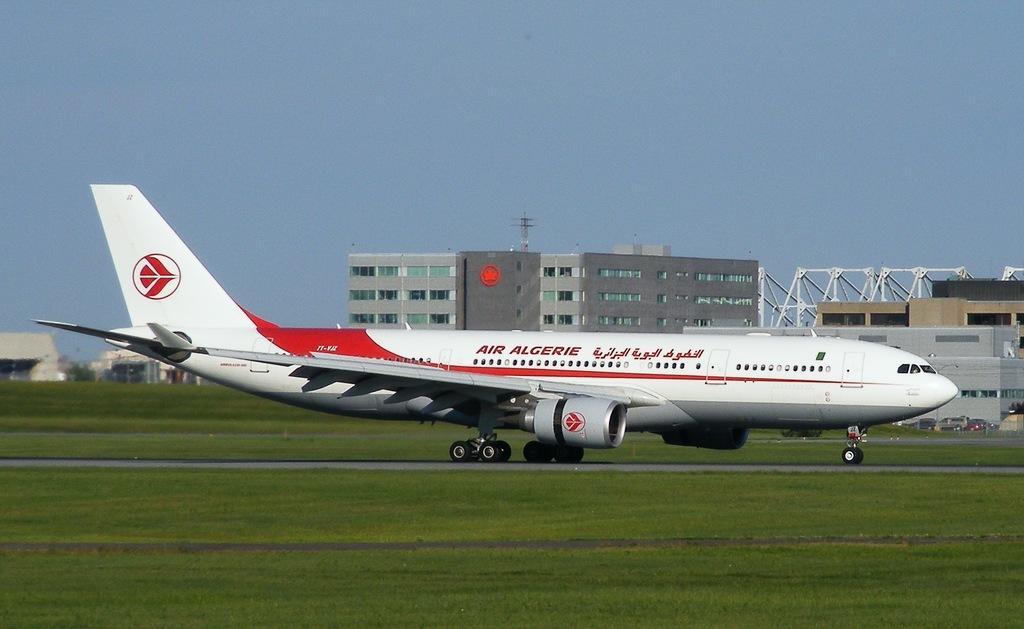In one or two sentences, can you explain what this image depicts? In the center of the image there is an airplane. At the bottom of the image there is grass on the surface. In the background of the image there are buildings, cars and sky. 